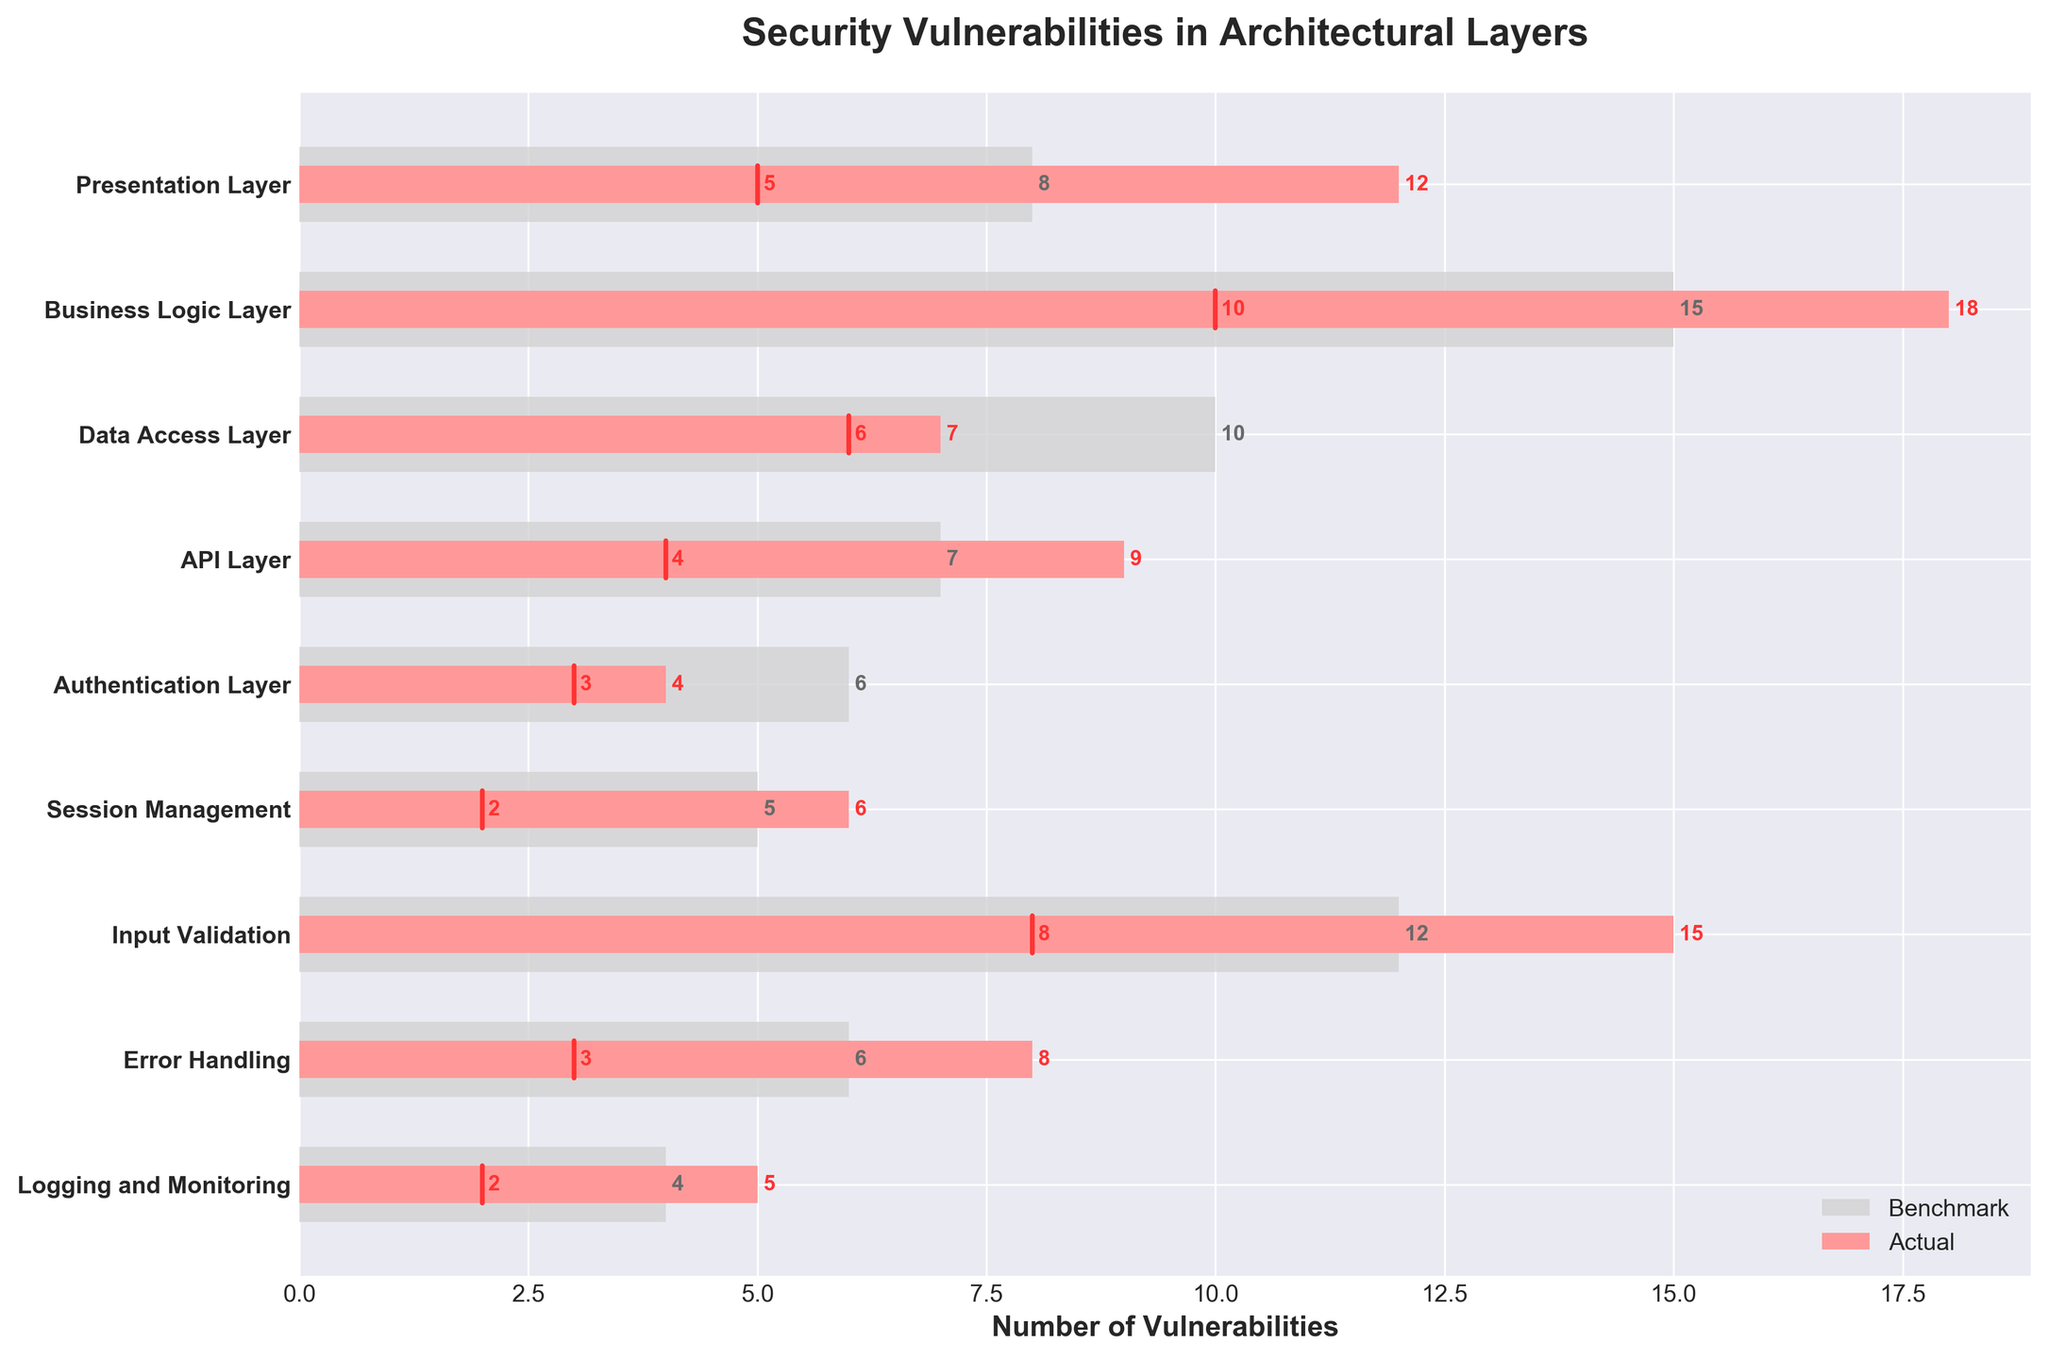What is the title of the figure? The title of the figure is found at the top center of the chart. It summarizes what the figure is about. The title in this case is "Security Vulnerabilities in Architectural Layers".
Answer: Security Vulnerabilities in Architectural Layers How many layers are assessed in the figure? The total number of layers assessed can be determined by counting the unique categories listed on the y-axis. There are nine categories listed.
Answer: Nine Which layer shows the highest number of actual vulnerabilities? To find this, we compare the red bars (actual vulnerabilities) for all layers. The "Business Logic Layer" has the longest red bar, indicating the highest number of actual vulnerabilities.
Answer: Business Logic Layer What is the difference between the actual vulnerabilities and the benchmark in the Business Logic Layer? For the Business Logic Layer, the actual vulnerabilities are 18 and the benchmark is 15. The difference is calculated by subtracting the benchmark from the actual vulnerabilities: 18 - 15.
Answer: 3 How does the number of actual vulnerabilities in the Data Access Layer compare to its benchmark? We look at the bars for the Data Access Layer. The actual vulnerabilities (7) are compared with the benchmark (10). The actual vulnerabilities are less than the benchmark.
Answer: Less than Which layer has the smallest discrepancy between actual vulnerabilities and the target? Compute the discrepancies for each layer by subtracting the target from the actual vulnerabilities (absolute value). The smallest discrepancy is where this difference is the least. "Session Management" has actual (6) and target (2), which is a difference of 4. However, "Logging and Monitoring" has actual (5) and target (2), making the discrepancy 3 (the smallest).
Answer: Logging and Monitoring Which layer has fewer actual vulnerabilities than its target? Check each layer to see if the actual vulnerabilities (red bar) are less than the corresponding target (marked with a vertical line). The "Authentication Layer" has 4 actual vulnerabilities, which is more than the target value. None of the layers have actual vulnerabilities less than their target value.
Answer: None What is the total number of benchmark vulnerabilities across all layers? Sum the benchmark values for all categories listed. 8 (Presentation) + 15 (Business) + 10 (Data Access) + 7 (API) + 6 (Auth) + 5 (Session) + 12 (Input) + 6 (Error Handling) + 4 (Logging) adds up to 73.
Answer: 73 Which layer deviates the most from the target? Calculate the absolute differences between each layer's actual vulnerabilities and their target. The largest difference will indicate the maximum deviation. Input Validation has actual (15) and target (8), resulting in a difference of 7, which is the largest deviation.
Answer: Input Validation 